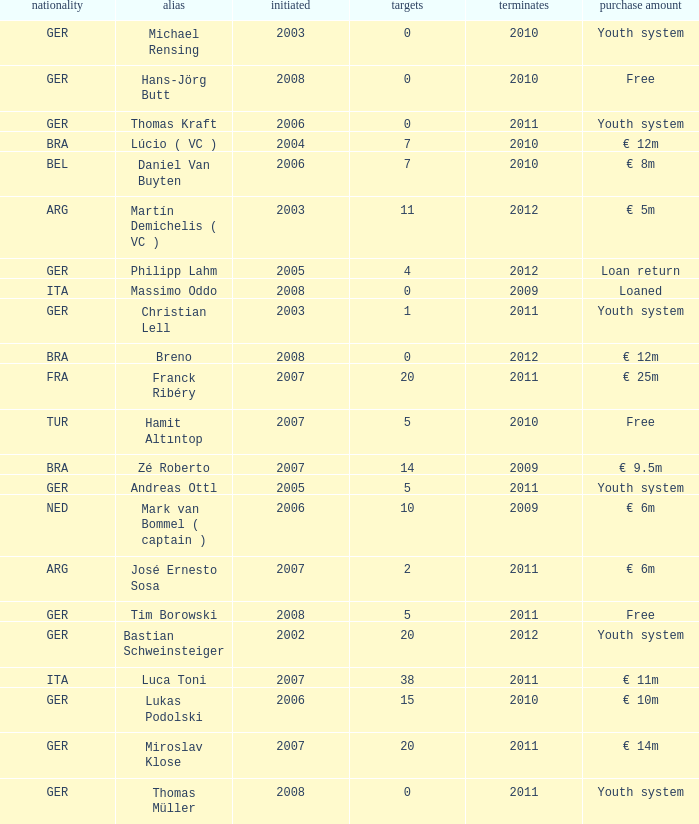What is the lowest year in since that had a transfer fee of € 14m and ended after 2011? None. 